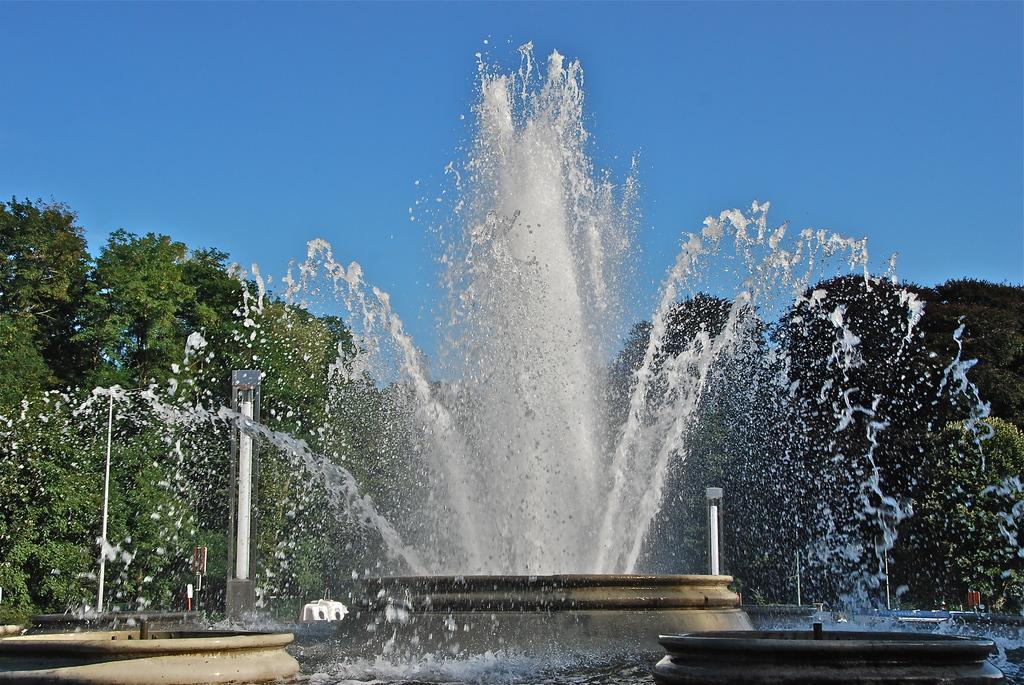Describe this image in one or two sentences. In the center of the image there is a fountain. In the background we can see some trees and light poles. At the top there is sky. 